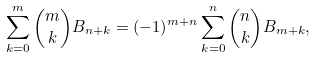Convert formula to latex. <formula><loc_0><loc_0><loc_500><loc_500>\sum _ { k = 0 } ^ { m } { m \choose k } B _ { n + k } = ( - 1 ) ^ { m + n } \sum _ { k = 0 } ^ { n } { n \choose k } B _ { m + k } ,</formula> 